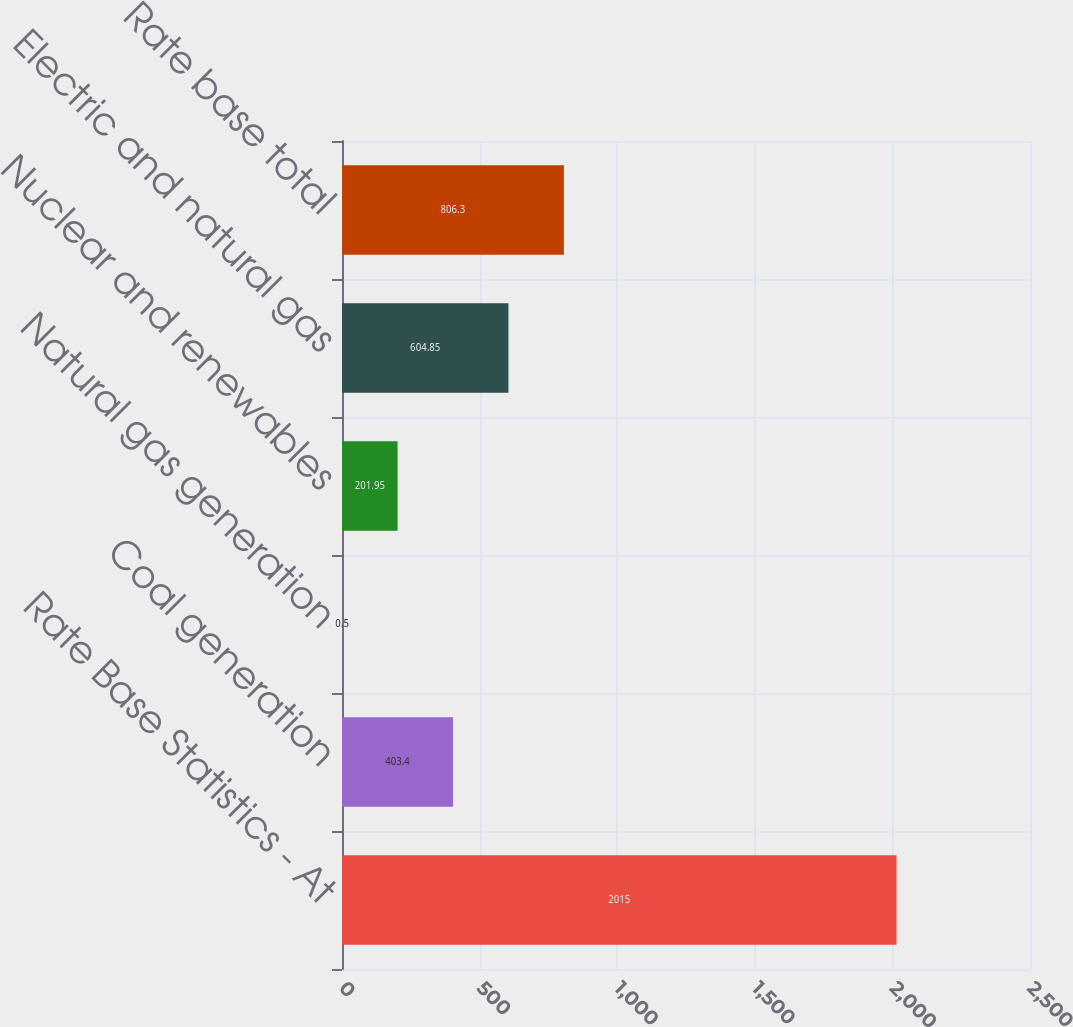<chart> <loc_0><loc_0><loc_500><loc_500><bar_chart><fcel>Rate Base Statistics - At<fcel>Coal generation<fcel>Natural gas generation<fcel>Nuclear and renewables<fcel>Electric and natural gas<fcel>Rate base total<nl><fcel>2015<fcel>403.4<fcel>0.5<fcel>201.95<fcel>604.85<fcel>806.3<nl></chart> 